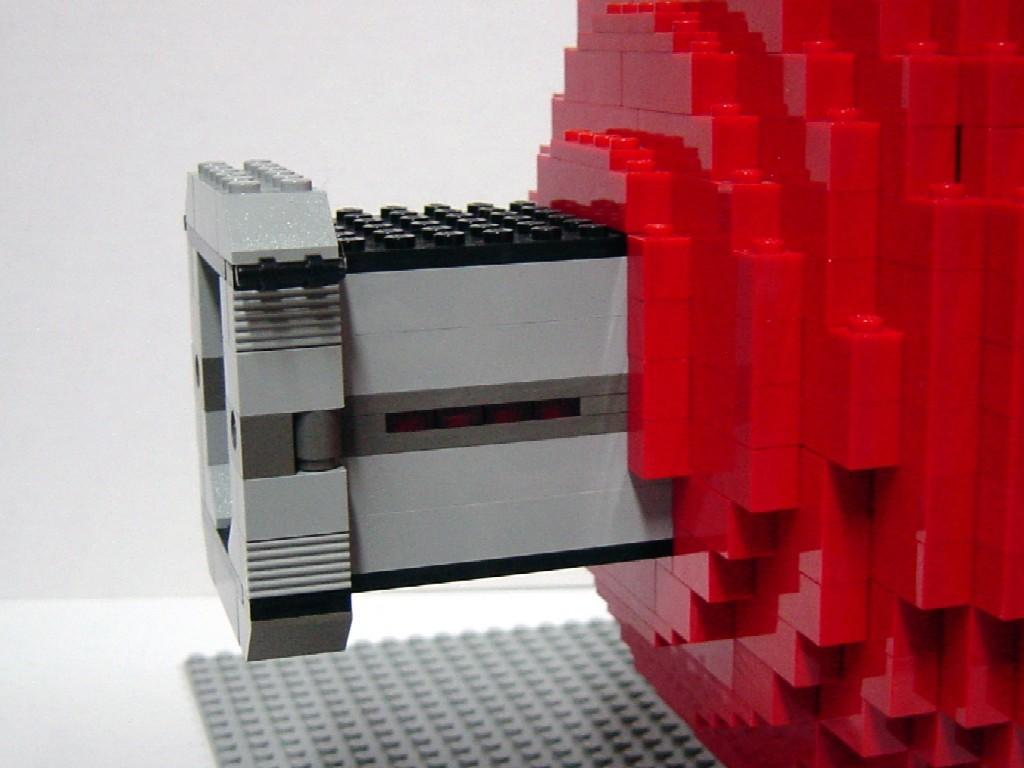What is the main subject of the image? The main subject of the image is a construction set toy. What elements of the toy can be seen in the image? There is a wall and a floor visible in the image. What type of insect can be seen crawling on the church in the image? There is no insect or church present in the image; it is a zoomed in picture of a construction set toy. What type of operation is being performed on the toy in the image? There is no operation being performed on the toy in the image; it is a still image of the construction set toy. 